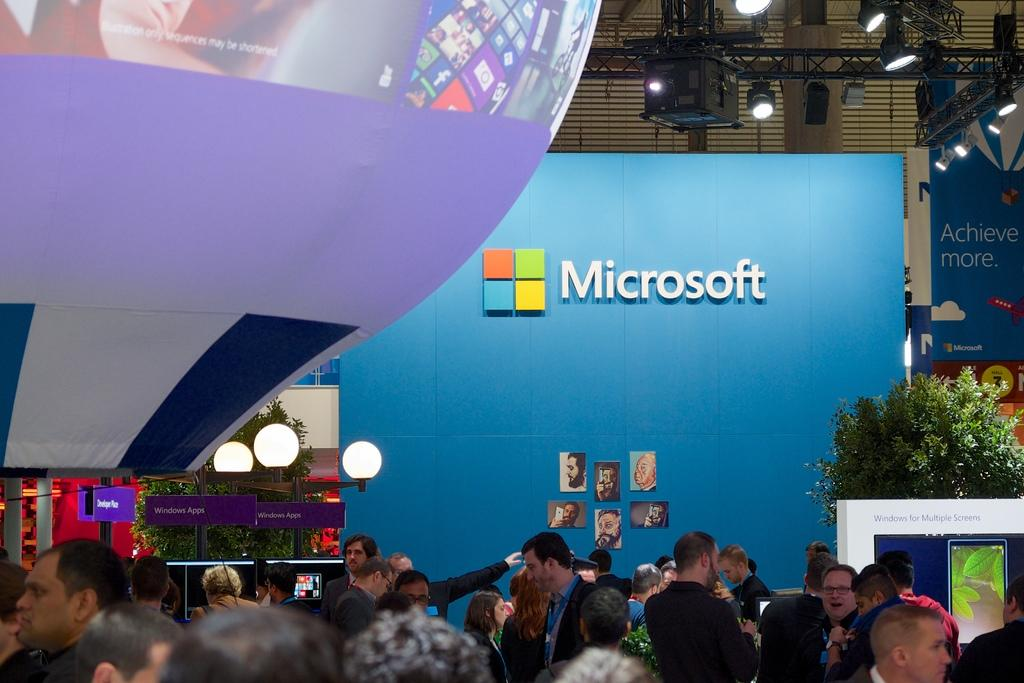How many people are in the group that is visible in the image? There is a group of people in the image, but the exact number is not specified. What type of natural vegetation can be seen in the image? There are trees in the image. What type of illumination is present in the image? There are lights in the image. What type of signage is present in the image? Name boards are present in the image. What type of decorative elements are visible in the image? Banners are visible in the image. What type of visual records are present in the image? Photos are present in the image. What other unspecified objects are present in the image? There are some unspecified objects in the image. Can you tell me how fast the current is flowing in the image? There is no reference to a current or any flowing water in the image. What type of animal is running in the image? There are no animals or running depicted in the image. 